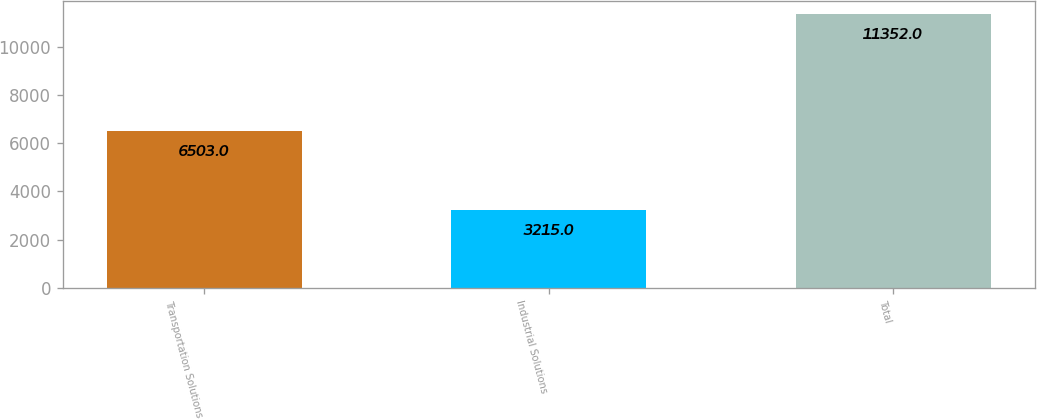Convert chart. <chart><loc_0><loc_0><loc_500><loc_500><bar_chart><fcel>Transportation Solutions<fcel>Industrial Solutions<fcel>Total<nl><fcel>6503<fcel>3215<fcel>11352<nl></chart> 